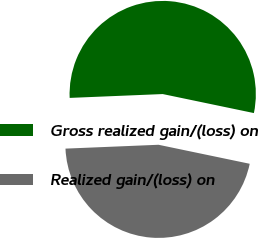<chart> <loc_0><loc_0><loc_500><loc_500><pie_chart><fcel>Gross realized gain/(loss) on<fcel>Realized gain/(loss) on<nl><fcel>53.93%<fcel>46.07%<nl></chart> 